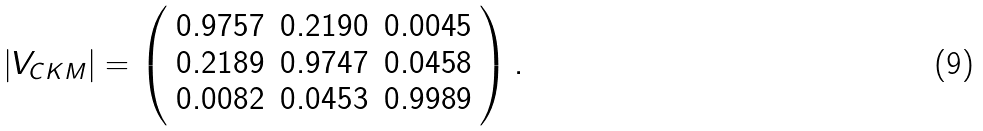Convert formula to latex. <formula><loc_0><loc_0><loc_500><loc_500>| V _ { C K M } | = \left ( \begin{array} { c c c } 0 . 9 7 5 7 & 0 . 2 1 9 0 & 0 . 0 0 4 5 \\ 0 . 2 1 8 9 & 0 . 9 7 4 7 & 0 . 0 4 5 8 \\ 0 . 0 0 8 2 & 0 . 0 4 5 3 & 0 . 9 9 8 9 \end{array} \right ) .</formula> 